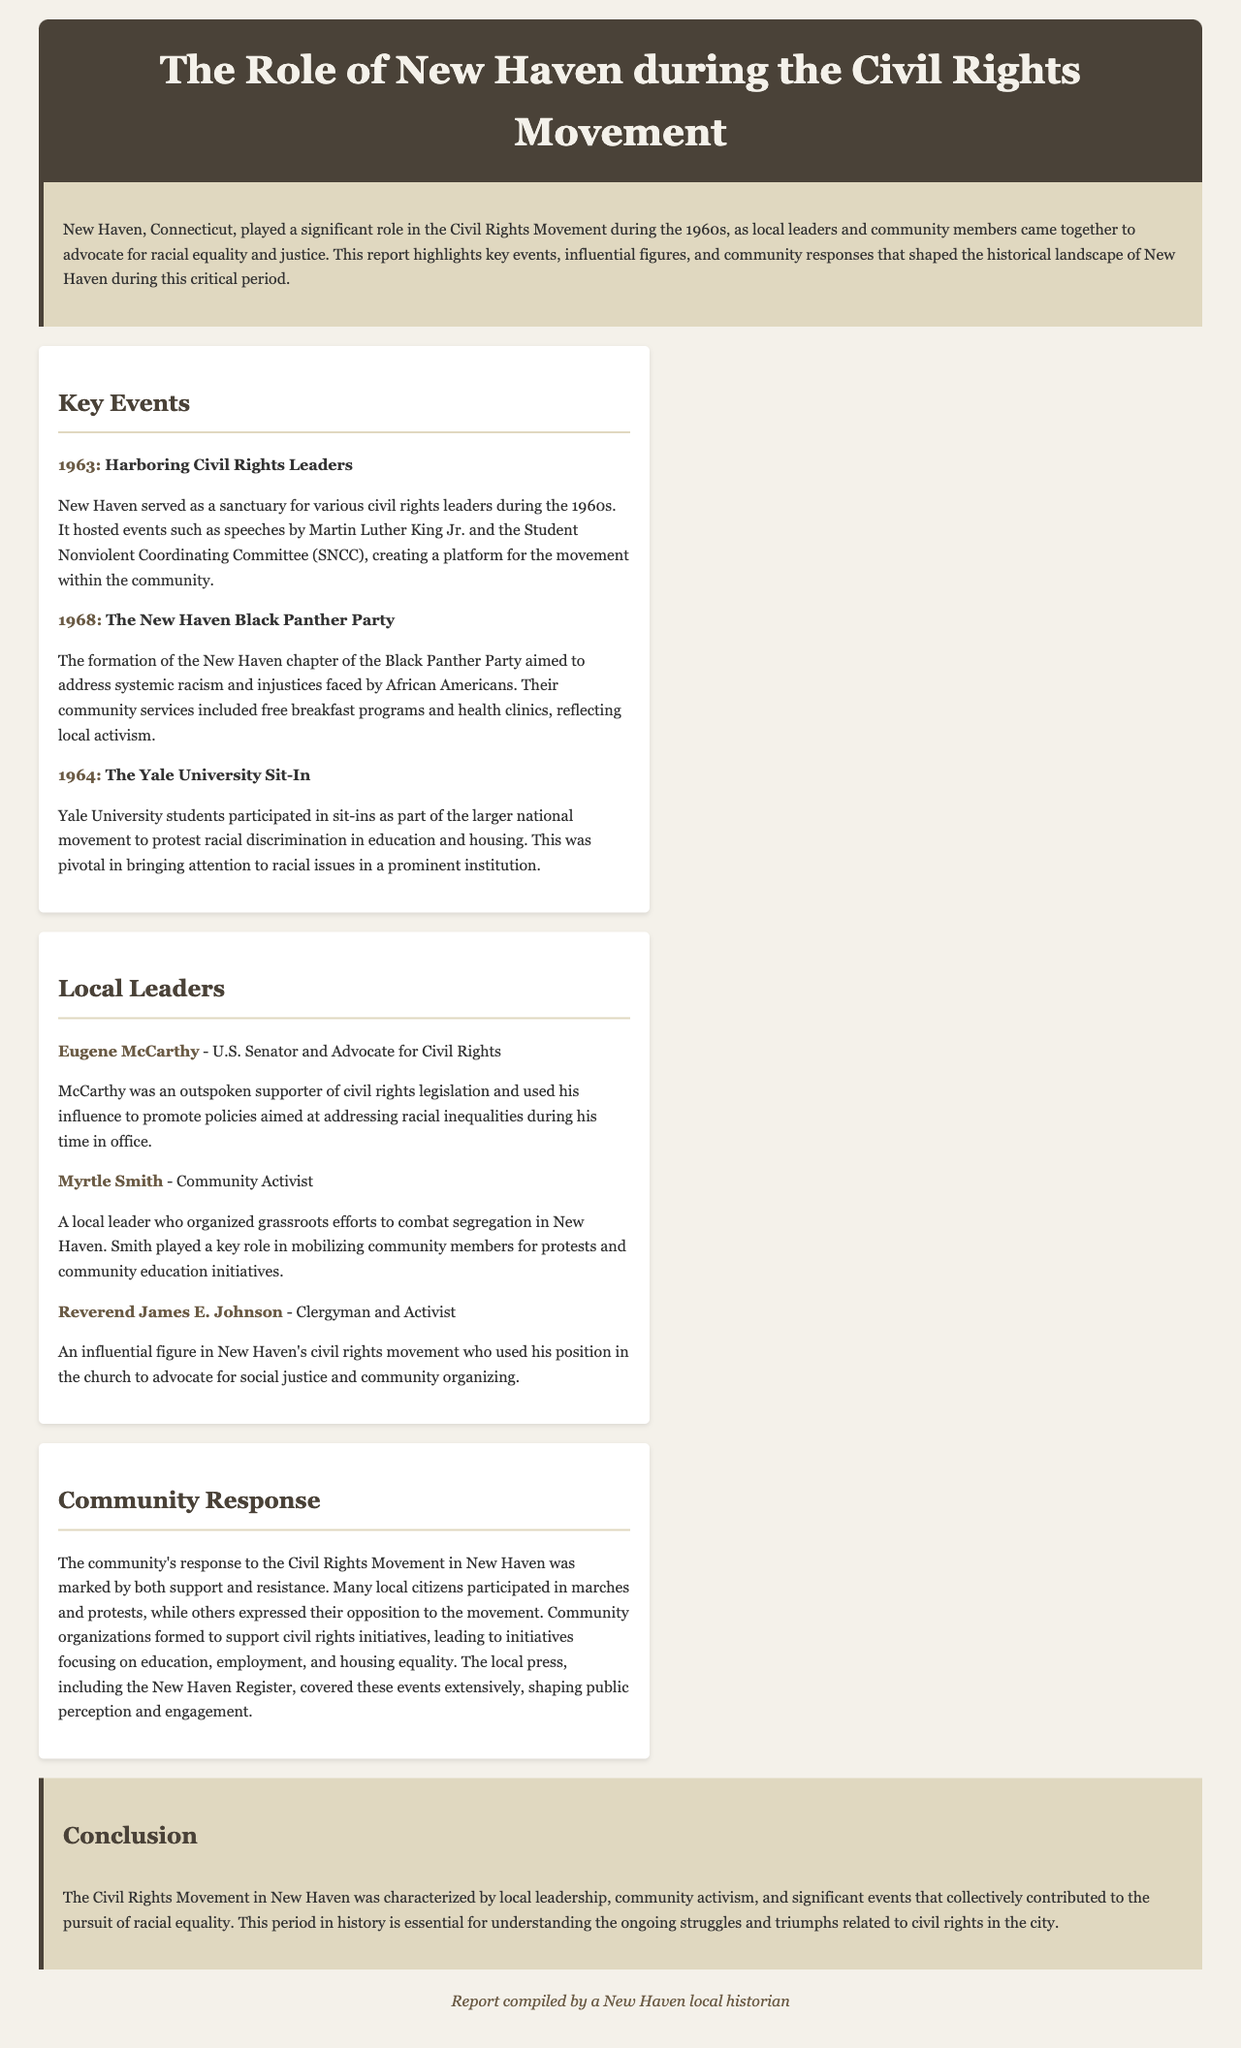what year did the New Haven Black Panther Party form? The document states the year of formation as 1968, discussing its aims and community services.
Answer: 1968 who was an outspoken supporter of civil rights legislation? Eugene McCarthy is highlighted in the document as a U.S. Senator who advocated for civil rights.
Answer: Eugene McCarthy what significant event involved Yale University students protesting racial discrimination? This event is referred to as "The Yale University Sit-In" in the document, which was part of a larger national movement.
Answer: The Yale University Sit-In who organized grassroots efforts to combat segregation in New Haven? Myrtle Smith is identified in the document as a key community activist for these efforts.
Answer: Myrtle Smith what did community organizations in New Haven focus on during the Civil Rights Movement? The document specifies that these organizations focused on education, employment, and housing equality.
Answer: Education, employment, and housing equality what was a major activity of the New Haven chapter of the Black Panther Party? The document describes free breakfast programs and health clinics as significant community services provided by the Party.
Answer: Free breakfast programs and health clinics how did the local press engage with the Civil Rights Movement events? The document indicates that the New Haven Register covered the events extensively, affecting public perception and engagement.
Answer: Covered extensively who delivered speeches that were hosted in New Haven in 1963? Martin Luther King Jr. is mentioned in the document as one of the civil rights leaders who spoke in New Haven.
Answer: Martin Luther King Jr what role did Reverend James E. Johnson play in New Haven's civil rights movement? The document describes him as an influential clergyman and activist advocating for social justice.
Answer: Influential clergyman and activist 